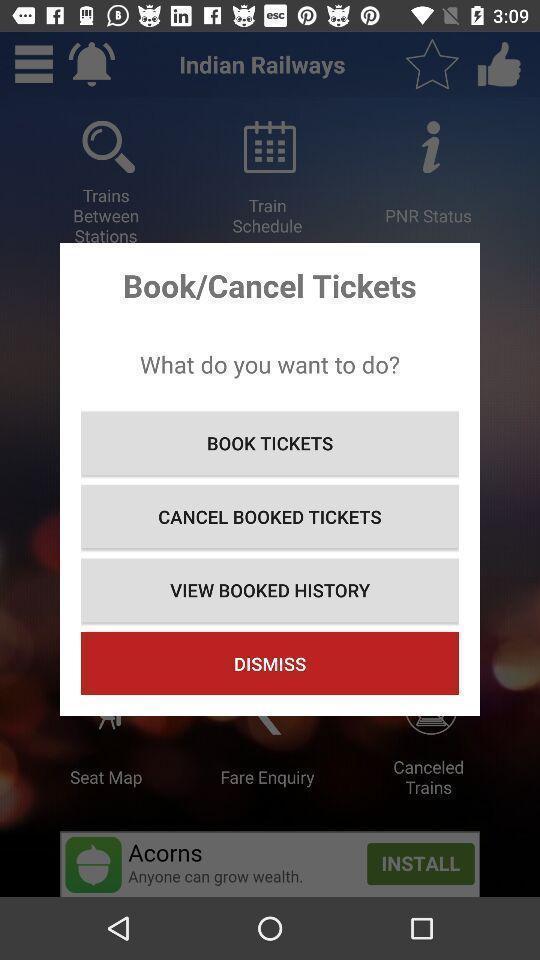Tell me what you see in this picture. Pop up showing various options in app. 